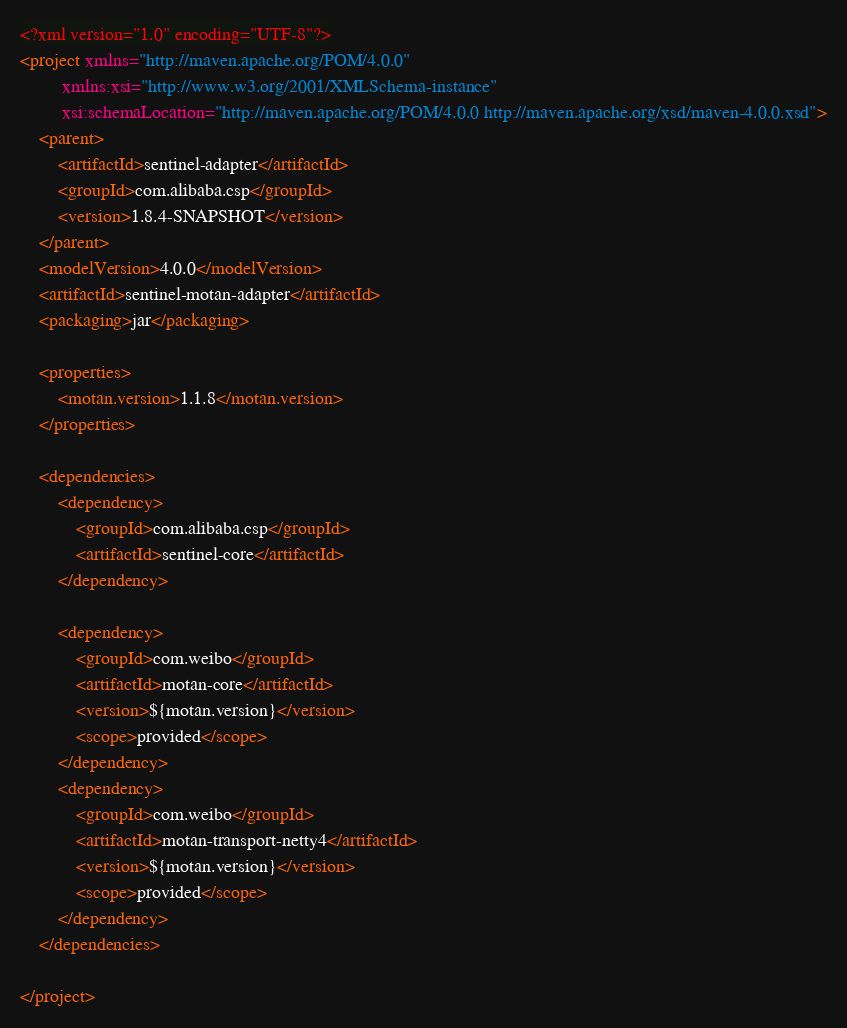Convert code to text. <code><loc_0><loc_0><loc_500><loc_500><_XML_><?xml version="1.0" encoding="UTF-8"?>
<project xmlns="http://maven.apache.org/POM/4.0.0"
         xmlns:xsi="http://www.w3.org/2001/XMLSchema-instance"
         xsi:schemaLocation="http://maven.apache.org/POM/4.0.0 http://maven.apache.org/xsd/maven-4.0.0.xsd">
    <parent>
        <artifactId>sentinel-adapter</artifactId>
        <groupId>com.alibaba.csp</groupId>
        <version>1.8.4-SNAPSHOT</version>
    </parent>
    <modelVersion>4.0.0</modelVersion>
    <artifactId>sentinel-motan-adapter</artifactId>
    <packaging>jar</packaging>

    <properties>
        <motan.version>1.1.8</motan.version>
    </properties>

    <dependencies>
        <dependency>
            <groupId>com.alibaba.csp</groupId>
            <artifactId>sentinel-core</artifactId>
        </dependency>

        <dependency>
            <groupId>com.weibo</groupId>
            <artifactId>motan-core</artifactId>
            <version>${motan.version}</version>
            <scope>provided</scope>
        </dependency>
        <dependency>
            <groupId>com.weibo</groupId>
            <artifactId>motan-transport-netty4</artifactId>
            <version>${motan.version}</version>
            <scope>provided</scope>
        </dependency>
    </dependencies>

</project></code> 